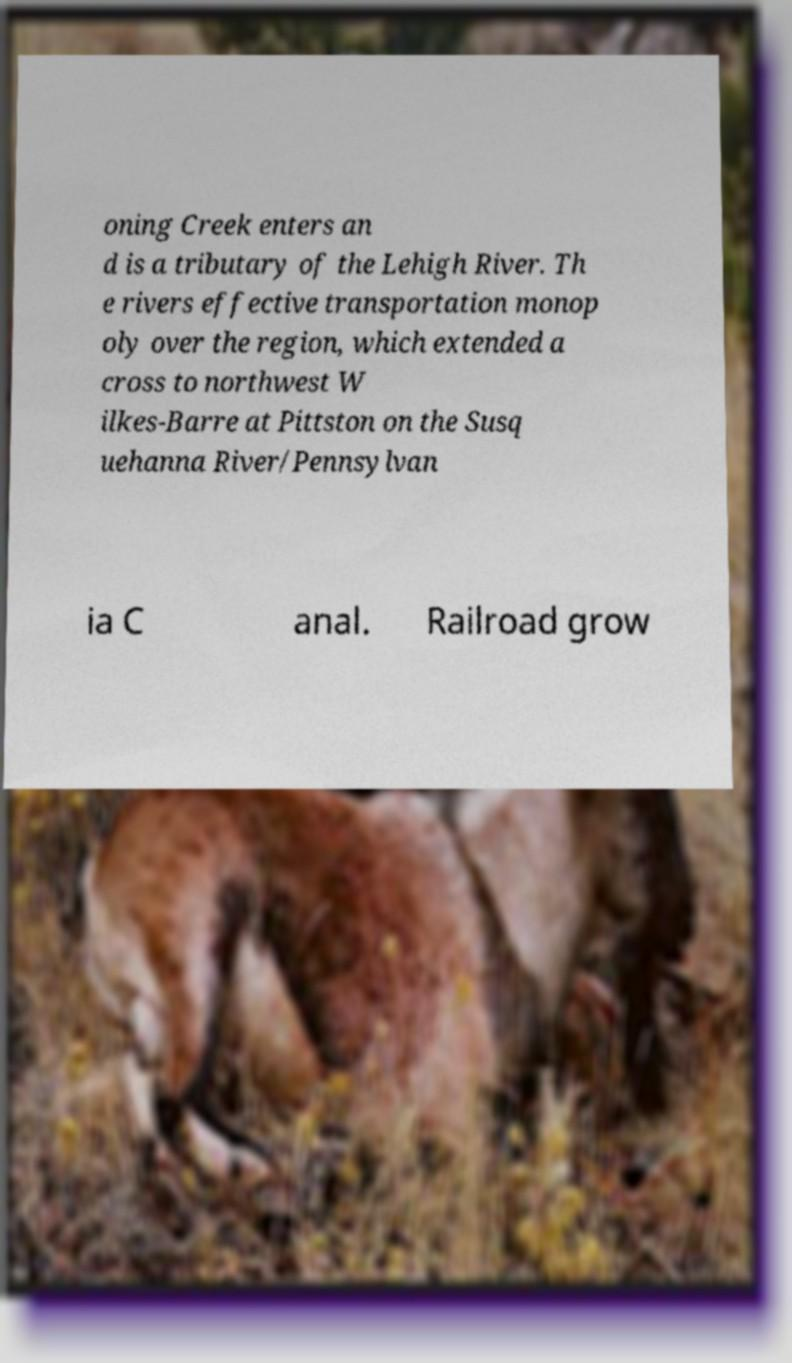Could you extract and type out the text from this image? oning Creek enters an d is a tributary of the Lehigh River. Th e rivers effective transportation monop oly over the region, which extended a cross to northwest W ilkes-Barre at Pittston on the Susq uehanna River/Pennsylvan ia C anal. Railroad grow 